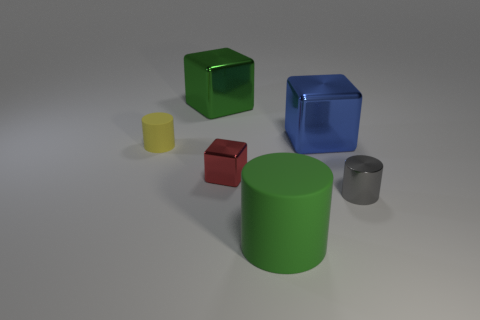Is there a large green thing that has the same material as the yellow cylinder?
Give a very brief answer. Yes. What shape is the blue shiny thing?
Give a very brief answer. Cube. Is the gray cylinder the same size as the green shiny object?
Your answer should be very brief. No. The green object in front of the blue shiny object has what shape?
Make the answer very short. Cylinder. There is a big green object behind the green cylinder; is it the same shape as the small metal object that is behind the gray metal cylinder?
Your response must be concise. Yes. Are there an equal number of small shiny objects that are behind the small gray metallic thing and tiny red things?
Ensure brevity in your answer.  Yes. There is another tiny thing that is the same shape as the blue shiny object; what is it made of?
Give a very brief answer. Metal. There is a small yellow thing behind the big thing in front of the tiny yellow thing; what is its shape?
Your answer should be very brief. Cylinder. Is the blue block on the right side of the tiny red shiny block made of the same material as the small gray cylinder?
Provide a short and direct response. Yes. Is the number of small red things in front of the tiny block the same as the number of tiny matte objects behind the yellow rubber cylinder?
Make the answer very short. Yes. 